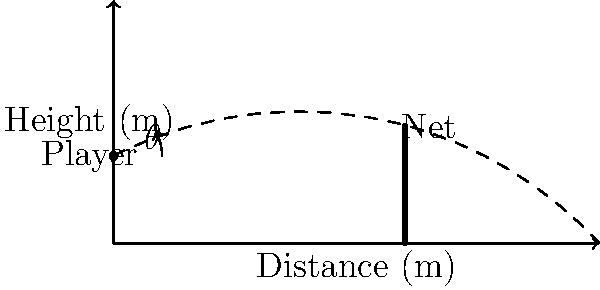As a sports commentator covering a beach volleyball match in Hawaii, you notice a player attempting to serve the ball over the net. The player is standing 6 meters away from the net, which is 2.43 meters high. If the player releases the ball at a height of 1.8 meters, what is the minimum angle (in degrees) at which the player should hit the ball to clear the net, assuming no air resistance and neglecting the ball's size? Let's approach this step-by-step:

1) First, we need to identify the relevant triangle. The base of our triangle is the distance from the player to the net (6 m), and the height is the difference between the net height and the release height (2.43 m - 1.8 m = 0.63 m).

2) We can use the tangent function to find the angle. The tangent of an angle is the opposite side divided by the adjacent side.

3) In this case:
   $tan(\theta) = \frac{opposite}{adjacent} = \frac{0.63}{6}$

4) To find $\theta$, we need to use the inverse tangent (arctan) function:
   $\theta = arctan(\frac{0.63}{6})$

5) Using a calculator or computing software:
   $\theta = arctan(0.105) \approx 5.99°$

6) However, this is the angle to barely touch the top of the net. To clear the net, the angle needs to be slightly larger than this.

7) To account for this, we should round up to the nearest degree.

Therefore, the minimum angle to clear the net is 6°.
Answer: 6° 